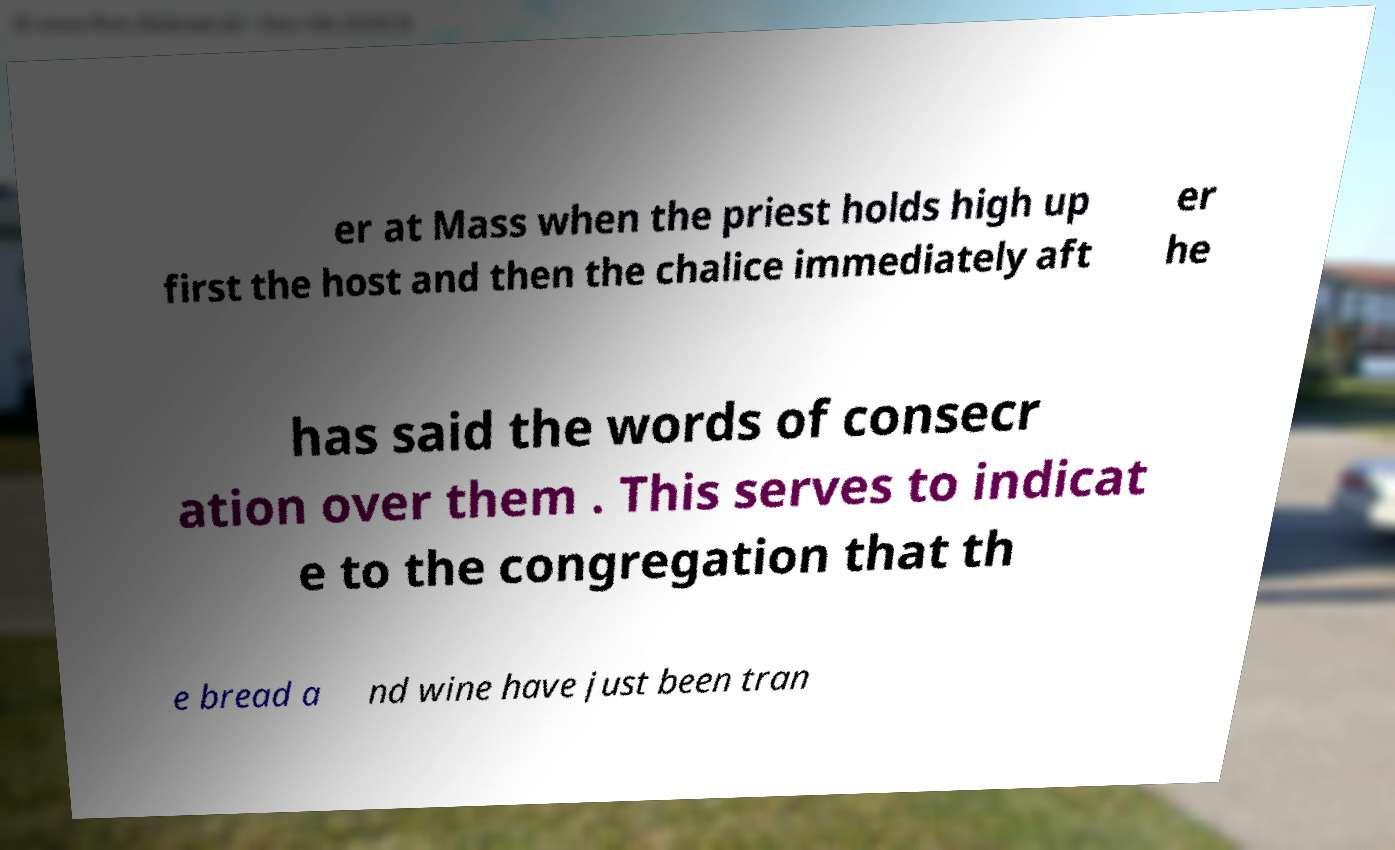There's text embedded in this image that I need extracted. Can you transcribe it verbatim? er at Mass when the priest holds high up first the host and then the chalice immediately aft er he has said the words of consecr ation over them . This serves to indicat e to the congregation that th e bread a nd wine have just been tran 